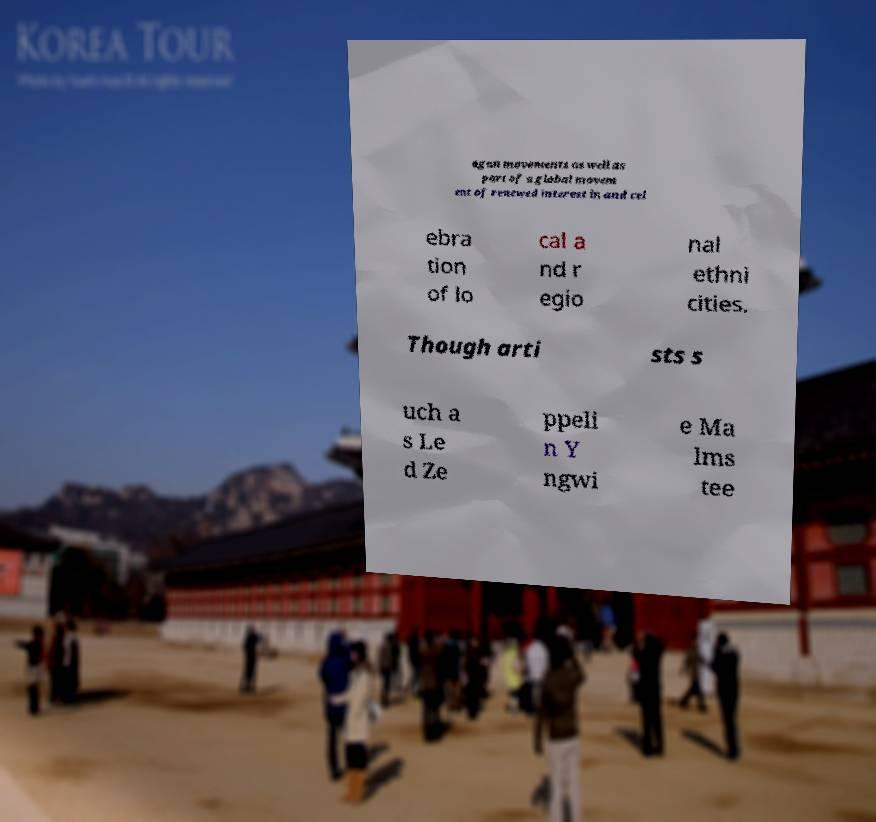Please identify and transcribe the text found in this image. agan movements as well as part of a global movem ent of renewed interest in and cel ebra tion of lo cal a nd r egio nal ethni cities. Though arti sts s uch a s Le d Ze ppeli n Y ngwi e Ma lms tee 